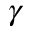Convert formula to latex. <formula><loc_0><loc_0><loc_500><loc_500>\gamma</formula> 